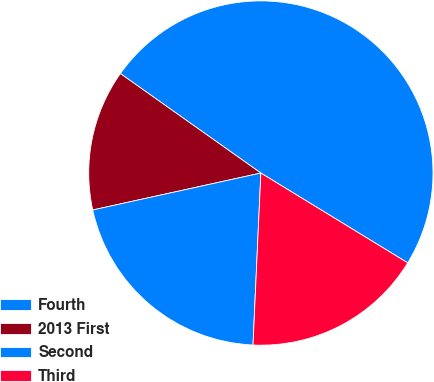Convert chart to OTSL. <chart><loc_0><loc_0><loc_500><loc_500><pie_chart><fcel>Fourth<fcel>2013 First<fcel>Second<fcel>Third<nl><fcel>48.93%<fcel>13.25%<fcel>20.83%<fcel>16.99%<nl></chart> 